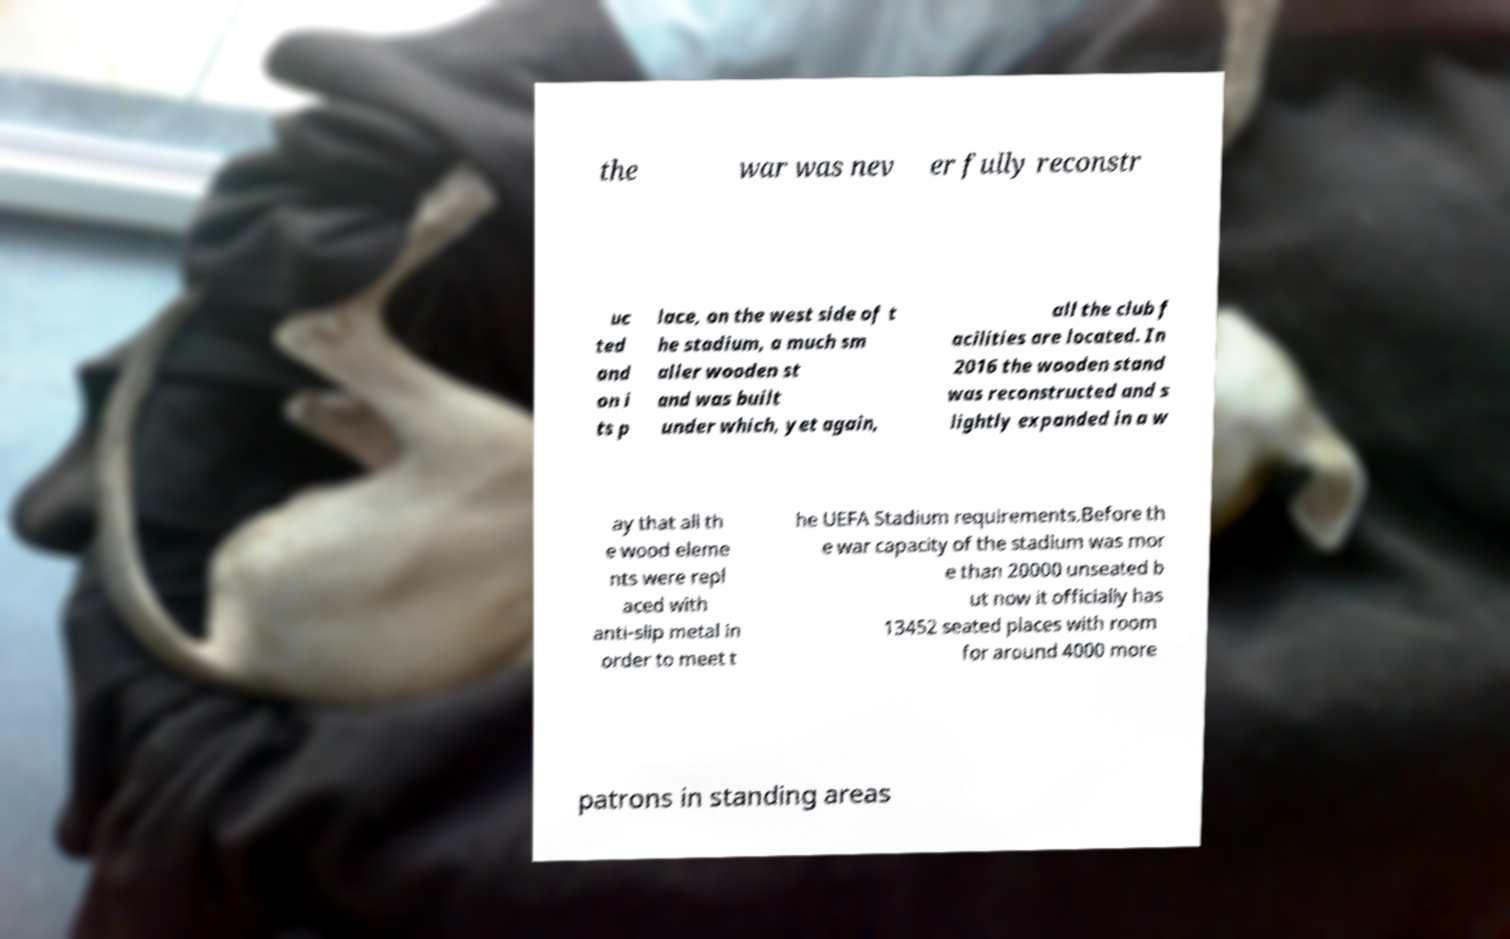Could you assist in decoding the text presented in this image and type it out clearly? the war was nev er fully reconstr uc ted and on i ts p lace, on the west side of t he stadium, a much sm aller wooden st and was built under which, yet again, all the club f acilities are located. In 2016 the wooden stand was reconstructed and s lightly expanded in a w ay that all th e wood eleme nts were repl aced with anti-slip metal in order to meet t he UEFA Stadium requirements.Before th e war capacity of the stadium was mor e than 20000 unseated b ut now it officially has 13452 seated places with room for around 4000 more patrons in standing areas 